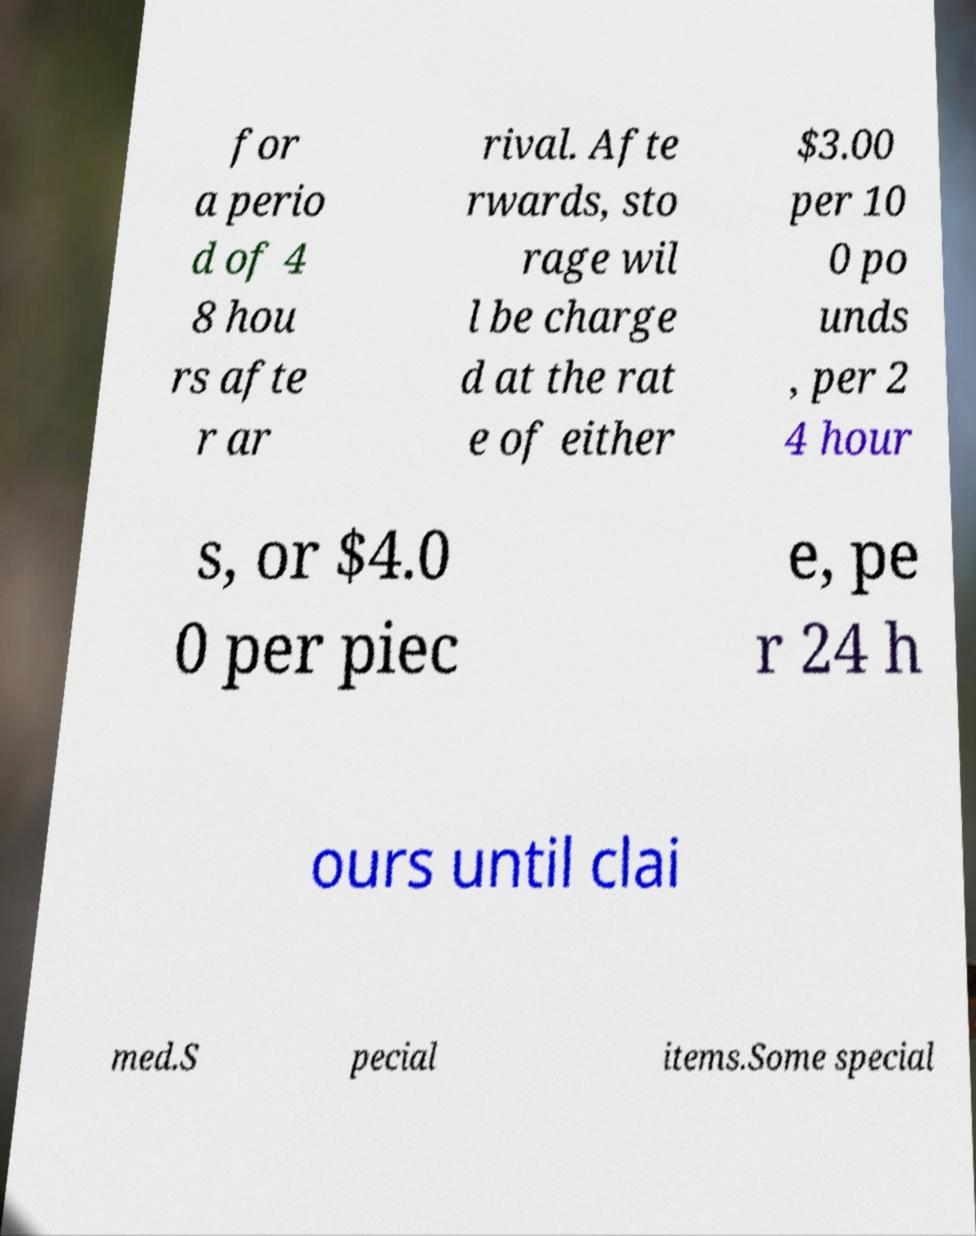Can you read and provide the text displayed in the image?This photo seems to have some interesting text. Can you extract and type it out for me? for a perio d of 4 8 hou rs afte r ar rival. Afte rwards, sto rage wil l be charge d at the rat e of either $3.00 per 10 0 po unds , per 2 4 hour s, or $4.0 0 per piec e, pe r 24 h ours until clai med.S pecial items.Some special 